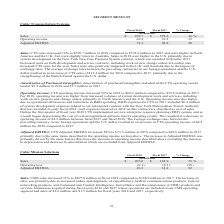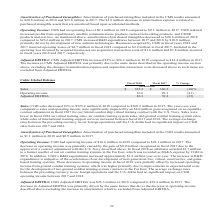According to Cubic's financial document, What is the percentage increase in CMS sales in 2018? According to the financial document, 23%. The relevant text states: "ted EBITDA 26.2 14.4 82 Sales: CMS sales increased 23% to $207.0 million in fiscal 2018 compared to $168.9 million in 2017. The increase in sales was prima..." Also, What is the decrease in amortization expense related to? purchased intangible assets that are amortized based upon accelerated methods. The document states: "on decrease in amortization expense is related to purchased intangible assets that are amortized based upon accelerated methods. Operating Income: CMS..." Also, What did the increase in expeditionary satellite communications products, tactical networking products, C2ISR products and services result in? The document shows two values: increase in sales and increased profits. From the document: "scal 2018 compared to $168.9 million in 2017. The increase in sales was primarily due to increased orders and shipments of expeditionary satellite com..." Additionally, In which year is the amount of amortization of purchased intangibles included in the CMS results larger? According to the financial document, 2017. The relevant text states: "Fiscal 2018 Fiscal 2017 % Change (in millions)..." Also, can you calculate: What is the change in sales in 2018? Based on the calculation: 207.0-168.9, the result is 38.1 (in millions). This is based on the information: "Sales $ 207.0 $ 168.9 23 % Operating loss (0.1) (9.3) (99) Sales $ 207.0 $ 168.9 23 % Operating loss (0.1) (9.3) (99)..." The key data points involved are: 168.9, 207.0. Also, can you calculate: What is the average adjusted EBITDA in 2018 and 2017? To answer this question, I need to perform calculations using the financial data. The calculation is: (26.2+14.4)/2, which equals 20.3 (in millions). This is based on the information: "Adjusted EBITDA 26.2 14.4 82 Sales: CMS sales increased 23% to $207.0 million in fiscal 2018 compared to $168.9 million in 20 Adjusted EBITDA 26.2 14.4 82 Sales: CMS sales increased 23% to $207.0 mill..." The key data points involved are: 14.4, 26.2. 